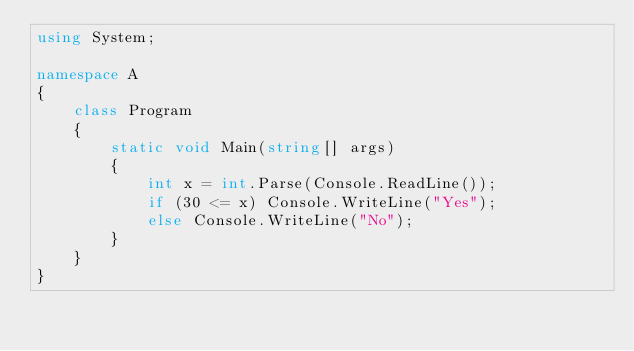Convert code to text. <code><loc_0><loc_0><loc_500><loc_500><_C#_>using System;

namespace A
{
    class Program
    {
        static void Main(string[] args)
        {
            int x = int.Parse(Console.ReadLine());
            if (30 <= x) Console.WriteLine("Yes");
            else Console.WriteLine("No");
        }
    }
}
</code> 